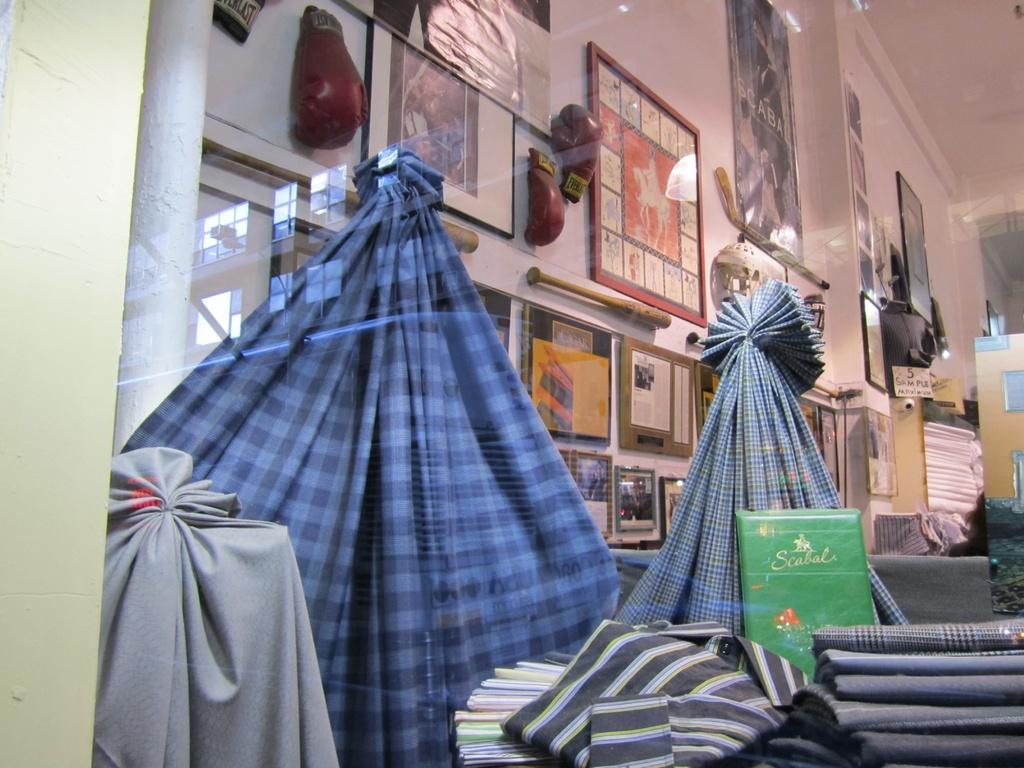What is in the image that can hold a liquid? There is a glass in the image. What can be seen through the glass? Clothes are visible through the glass. What is hanging on the wall in the image? There are frames on the wall in the image. What type of clothing accessory is present in the image? Gloves are present in the image. What is a flat, typically rectangular surface in the image? There is a board in the image. Can you describe any other objects in the image? There are other objects in the image, but their specific details are not mentioned in the provided facts. How many lizards are crawling on the board in the image? There are no lizards present in the image. What type of house is depicted in the image? The image does not show a house; it contains a glass, frames, gloves, and a board, among other objects. 